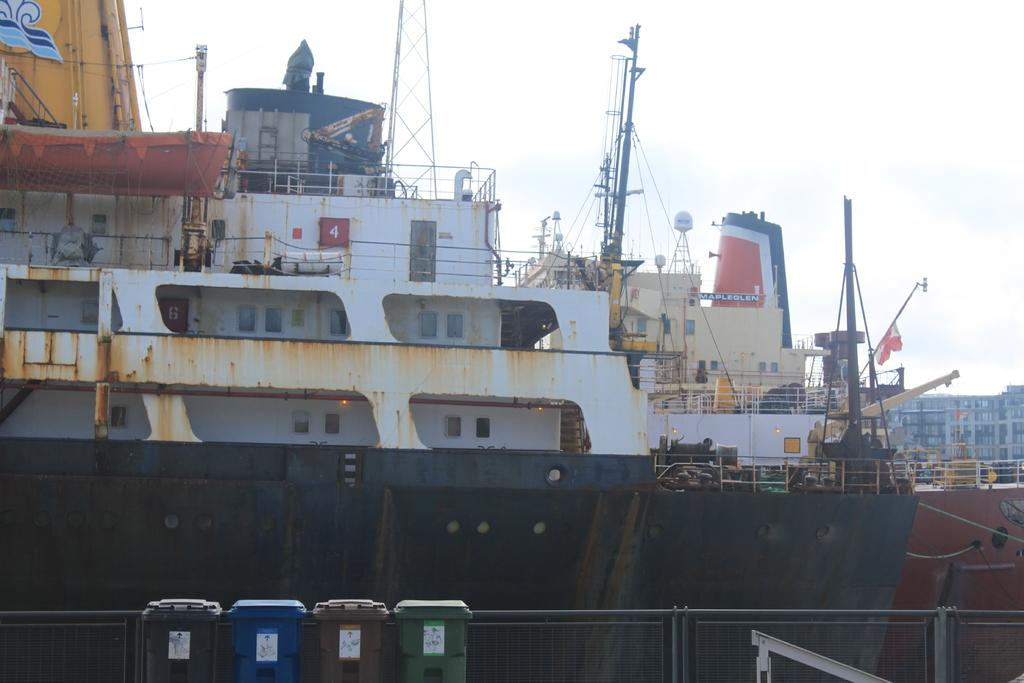Provide a one-sentence caption for the provided image. A large black and white rusty ship called the Mapleglen at dock behind some small garbage bins. 